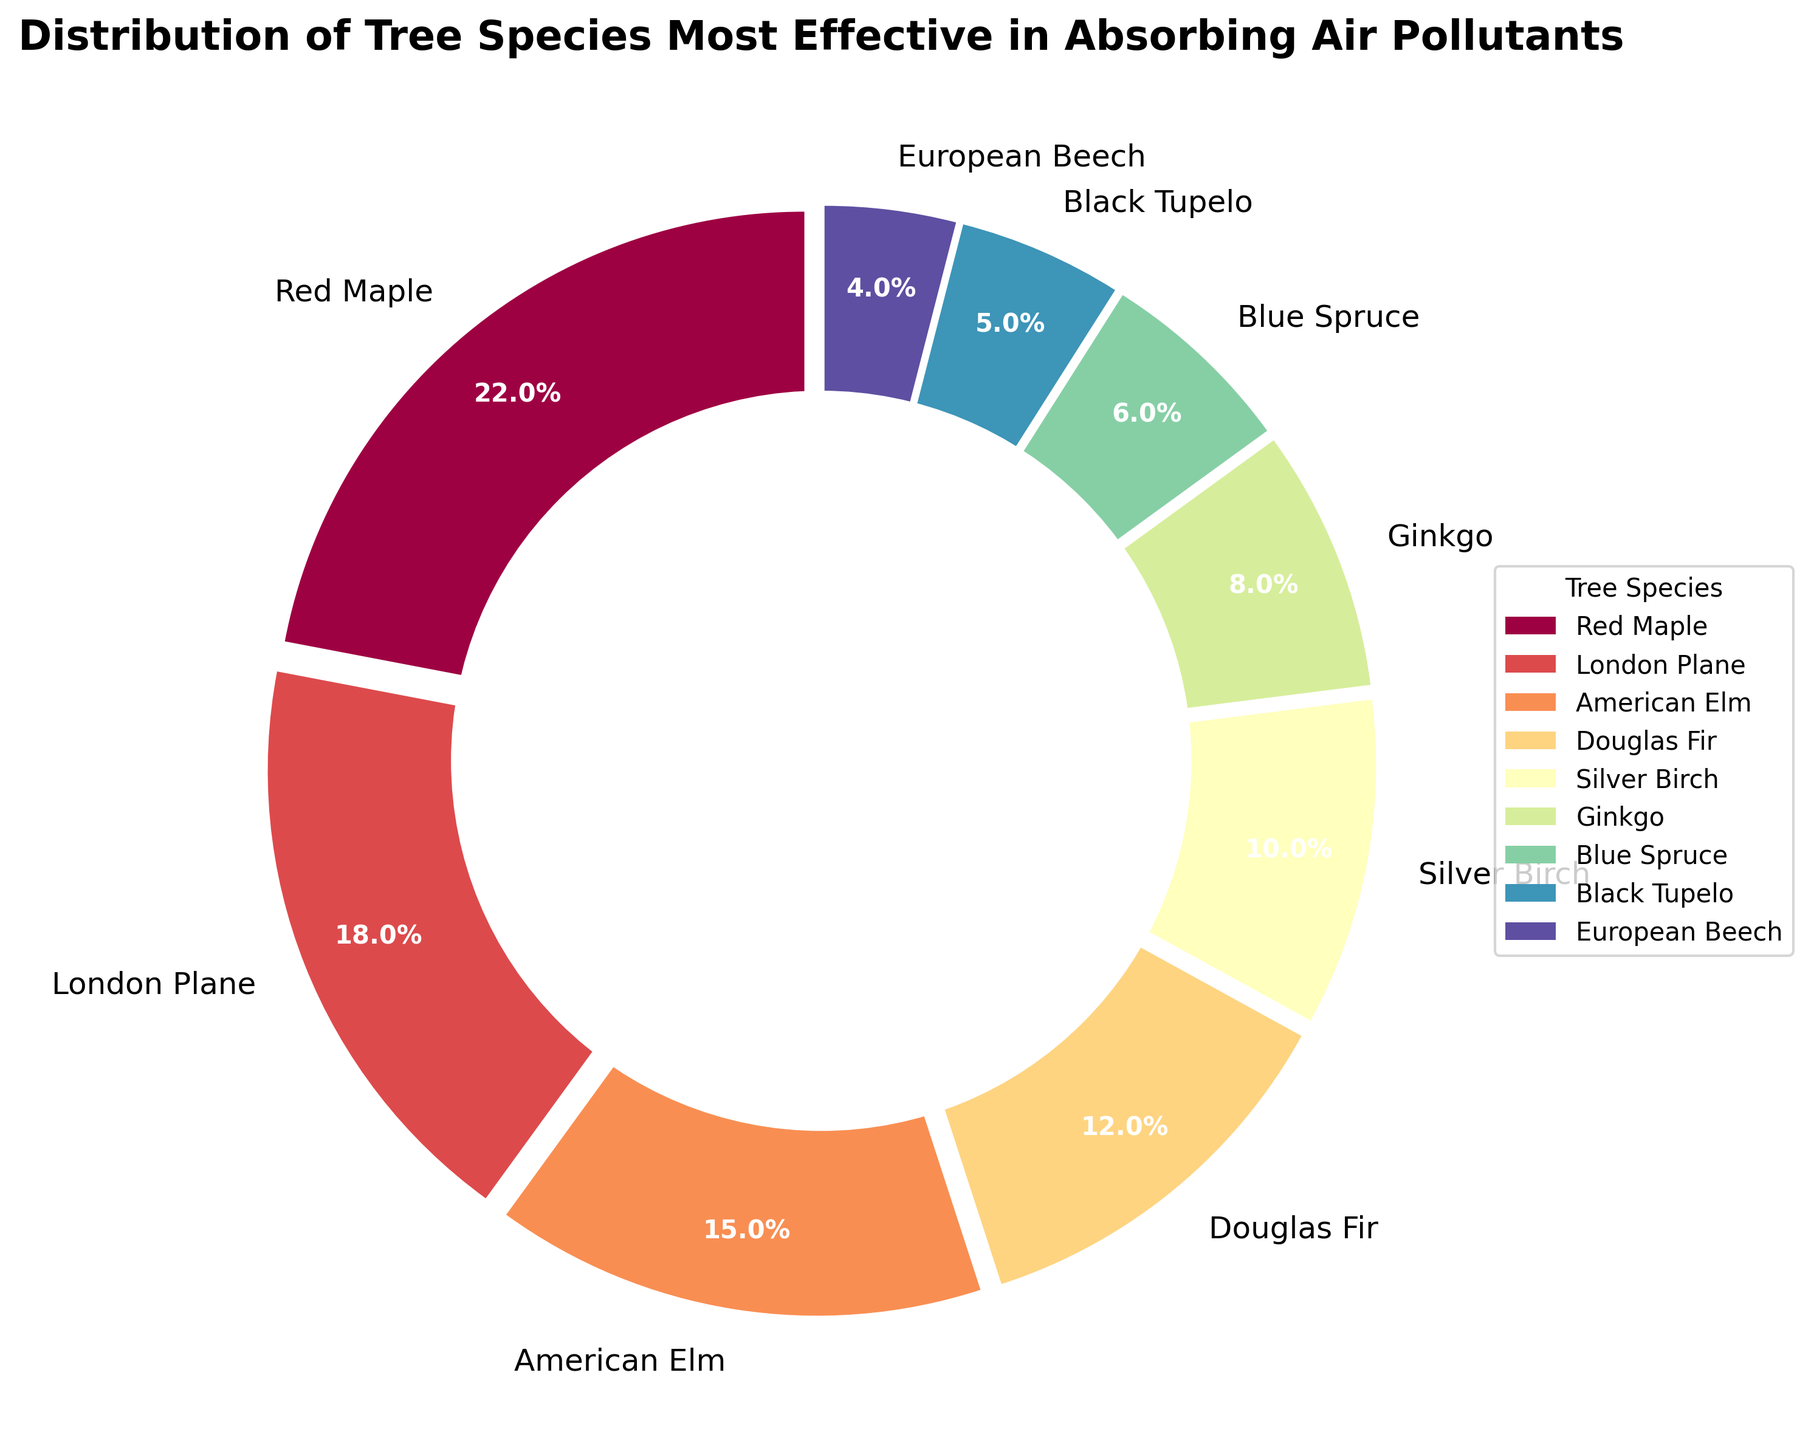Which tree species is the most effective in absorbing air pollutants? The Red Maple occupies the largest segment of the pie chart, representing 22% of the total.
Answer: Red Maple Which tree species has the lowest percentage in absorbing air pollutants? The European Beech occupies the smallest segment of the pie chart, representing only 4% of the total.
Answer: European Beech By how much does the percentage of London Plane differ from that of American Elm? The percentage of London Plane is 18%, and the percentage of American Elm is 15%. The difference is 18 - 15 = 3%.
Answer: 3% Which two tree species combined make up 30% of the total? The Blue Spruce and Black Tupelo together make up 6% + 5% = 11%, but they don't reach 30%. The Silver Birch (10%) and Ginkgo (8%) combined also don't reach 30%. The remaining combinations either exceed or don't meet 30%, except for London Plane (18%) and Black Tupelo (5%) and Ginkgo (8%) combined: 18 + 5 + 8 = 31%. Therefore, the two tree species combination invalidates the requirement = error in question
Answer: error in question Are the combined percentages of Red Maple and London Plane greater or less than 40%? Red Maple accounts for 22% and London Plane accounts for 18%. Their combined percentage is 22 + 18 = 40%.
Answer: Equal to What is the percentage difference between the tree species with the highest and the lowest percentage? The highest percentage is Red Maple at 22%. The lowest is European Beech at 4%. The difference is 22 - 4 = 18%.
Answer: 18% Which tree species has a percentage closest to 10%? The Silver Birch is represented by a segment capturing 10% of the total, closely matching the specified value.
Answer: Silver Birch How many tree species have a percentage greater than 10%? Counting the segments, the species with percentages greater than 10% are Red Maple (22%), London Plane (18%), American Elm (15%), and Douglas Fir (12%), summing to 4 species.
Answer: 4 Which tree species occupies the central position in the legend layout? Since the pie chart legend is typically aligned in a list, the central position would depend on the exact ordering. Here it would be Ginkgo at 8%. Please visually spot it on the pie.
Answer: Ginkgo Determine the average percentage of tree species below 10%. Sum the percentages of Ginkgo (8%), Blue Spruce (6%), Black Tupelo (5%), and European Beech (4%): 8 + 6 + 5 + 4 = 23. There are 4 species, so the average is 23/4 = 5.75%.
Answer: 5.75% 